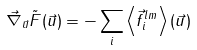Convert formula to latex. <formula><loc_0><loc_0><loc_500><loc_500>\vec { \nabla } _ { \vec { u } } \tilde { F } ( \vec { u } ) = - \sum _ { i } \left \langle \vec { f } ^ { l m } _ { i } \right \rangle ( \vec { u } )</formula> 